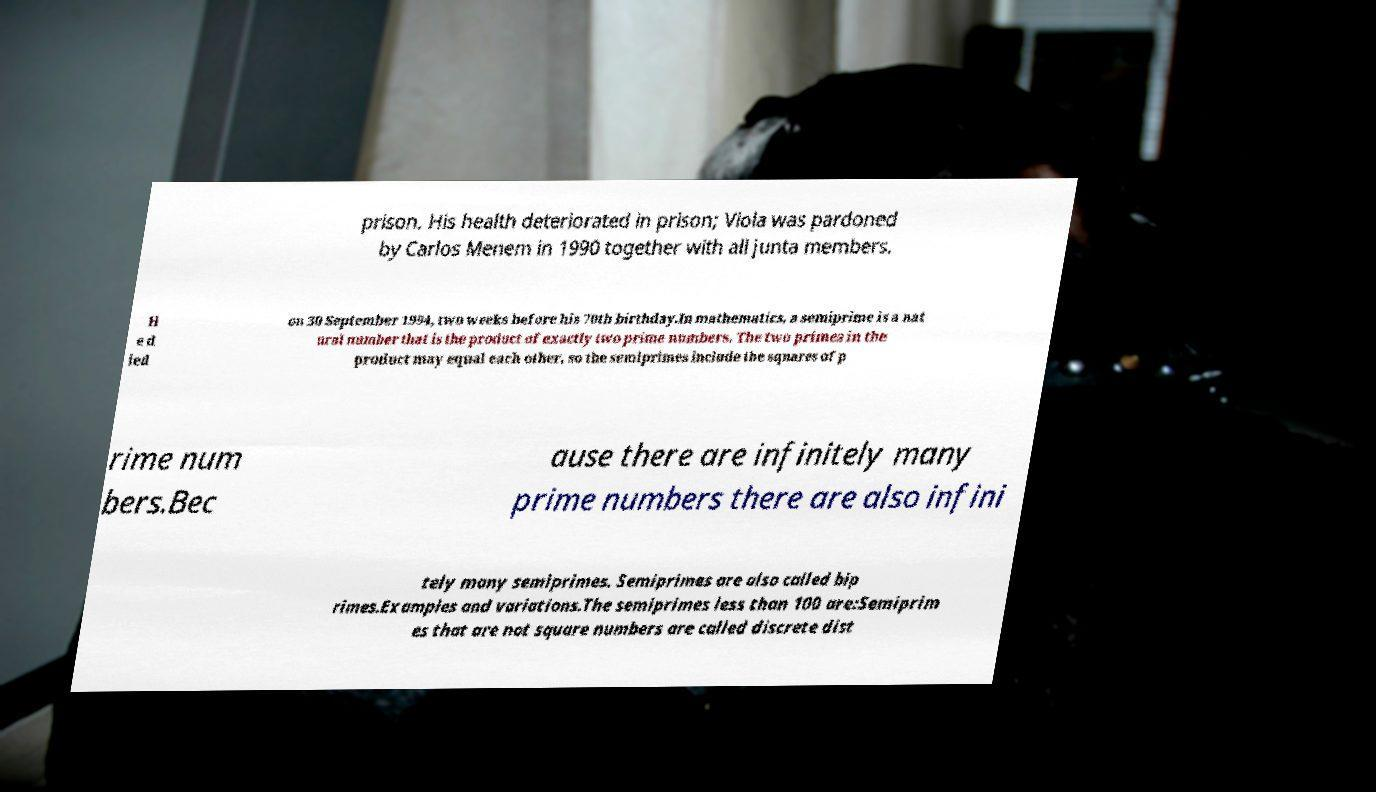Can you accurately transcribe the text from the provided image for me? prison. His health deteriorated in prison; Viola was pardoned by Carlos Menem in 1990 together with all junta members. H e d ied on 30 September 1994, two weeks before his 70th birthday.In mathematics, a semiprime is a nat ural number that is the product of exactly two prime numbers. The two primes in the product may equal each other, so the semiprimes include the squares of p rime num bers.Bec ause there are infinitely many prime numbers there are also infini tely many semiprimes. Semiprimes are also called bip rimes.Examples and variations.The semiprimes less than 100 are:Semiprim es that are not square numbers are called discrete dist 